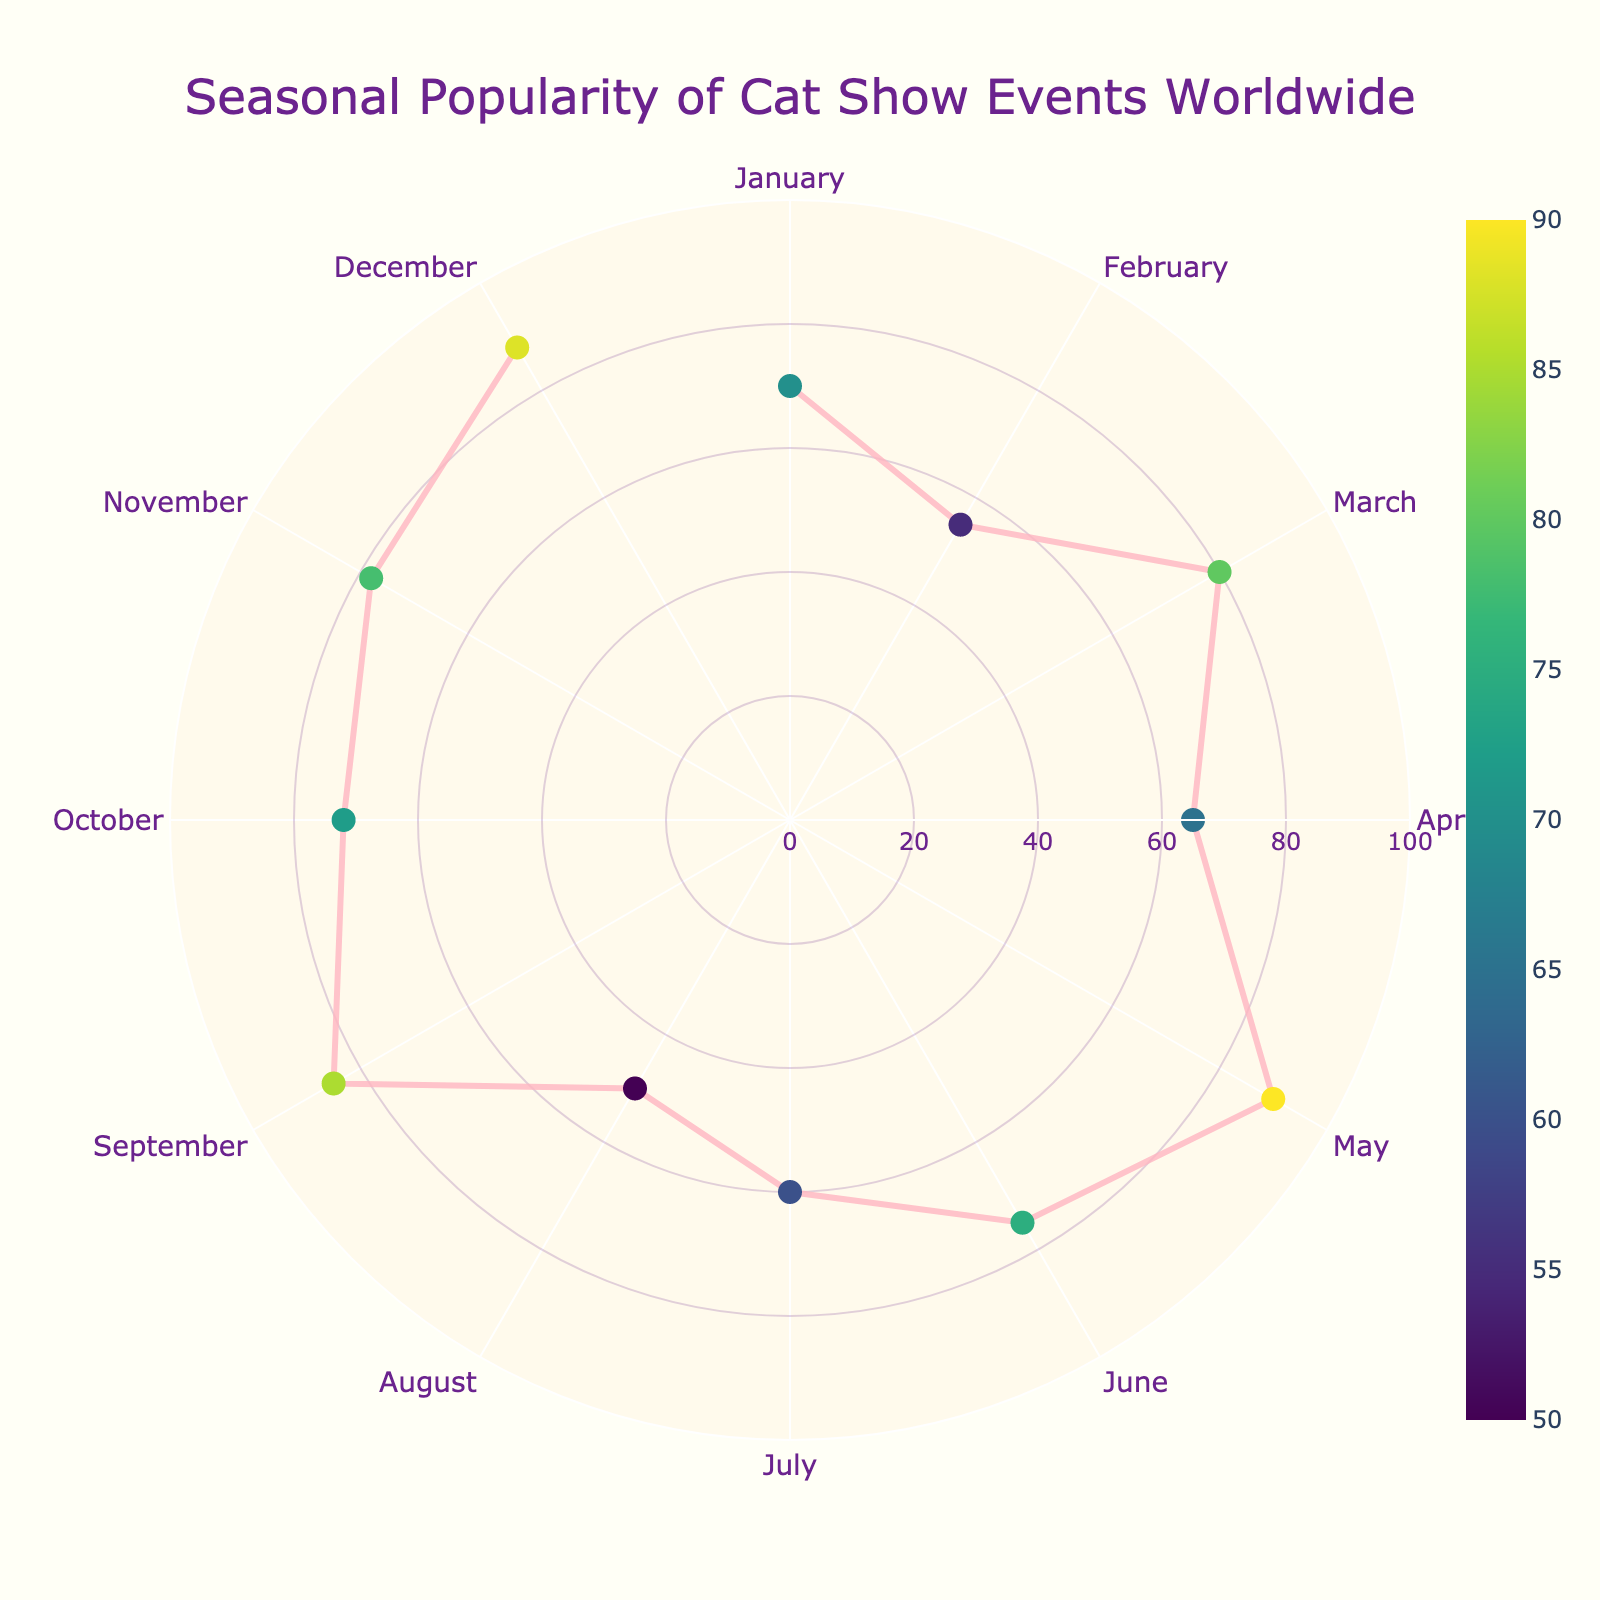What's the title of the polar chart? The title is displayed at the top of the chart. It describes the overall theme and focus of the visualization.
Answer: Seasonal Popularity of Cat Show Events Worldwide Which month has the highest popularity score? By looking at the radial axis labels and markers on the chart, identify the marker with the highest radial value and note its corresponding month.
Answer: May Which event is held in the month of December and what is its popularity? Hover over the marker corresponding to December on the angular axis to view the event name and its popularity score.
Answer: Luv-a-Cat Christmas Gala, 88 Compare the popularity of the "Supreme Cat Show" in May and the "Tokyo Cat Show" in August. Which is more popular? Locate both May and August on the angular axis, then compare the radial values (length of the markers) for these two months.
Answer: Supreme Cat Show What is the average popularity of events from January to June inclusive? Sum the popularity scores for the months January through June and divide the total by the number of months (6).
Answer: 72.5 Which event has the lowest popularity, and in which month does it occur? Identify the event with the smallest radial value by comparing all markers on the chart. Note the corresponding month for this event.
Answer: Tokyo Cat Show, August How does the popularity of the "Paris Cat Extravaganza" in October compare to the "Sydney Royal Cat Show" in November? Observe the markers for October and November, compare their radial values to determine which is higher.
Answer: Sydney Royal Cat Show Describe the color variation in the markers and explain what it represents. The colors of the markers vary according to a color scale (Viridis) and represent different popularity scores. Markers with lower popularity are lighter, while higher popularity scores are darker.
Answer: Color scale representing popularity What range does the radial axis cover in this chart? Observe the radial axis, noting the minimum and maximum values indicated by the tick marks.
Answer: 0 to 100 How many events have a popularity score greater than 70? Count the number of markers that fall beyond the radial value of 70, around the circular grid.
Answer: 9 